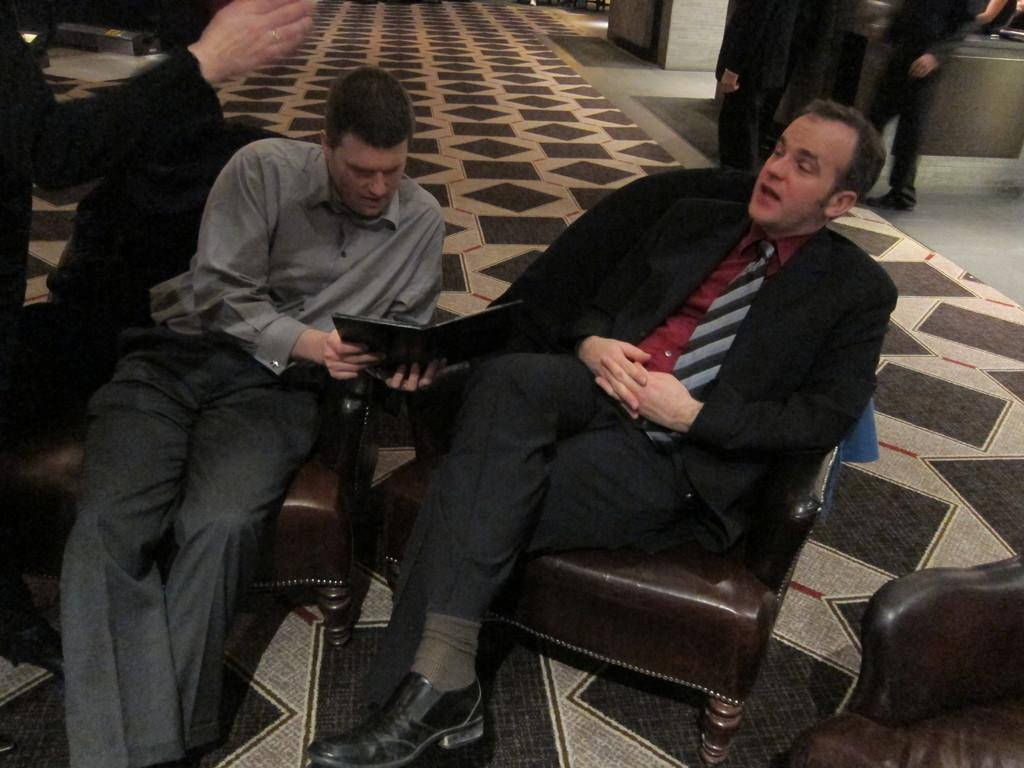What are the people in the image doing? The people in the image are sitting on chairs. Can you describe the setting in the image? There are more people visible in the background of the image. What part of a person can be seen in the image? A hand of a person is visible in the image. What type of boundary is present in the image? There is no boundary visible in the image. Can you describe the hose used by the people in the image? There is no hose present in the image. 